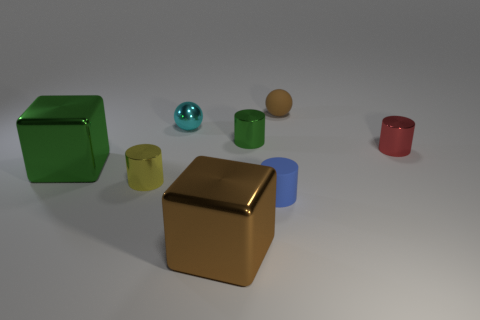How many cylinders are large blue matte things or small blue objects?
Your answer should be compact. 1. Are the big brown block and the small blue cylinder made of the same material?
Offer a terse response. No. There is a green object that is the same shape as the brown metallic object; what size is it?
Offer a very short reply. Large. The tiny thing that is in front of the tiny green metallic cylinder and left of the big brown metallic object is made of what material?
Make the answer very short. Metal. Is the number of tiny brown spheres to the left of the blue matte thing the same as the number of small gray metal things?
Your answer should be compact. Yes. How many objects are tiny objects left of the brown rubber object or big blue objects?
Keep it short and to the point. 4. Do the large cube to the right of the small cyan metallic object and the tiny rubber ball have the same color?
Provide a short and direct response. Yes. What is the size of the green thing in front of the tiny red thing?
Your response must be concise. Large. What shape is the rubber thing behind the large block behind the brown block?
Your answer should be compact. Sphere. What color is the matte object that is the same shape as the red metal object?
Provide a succinct answer. Blue. 